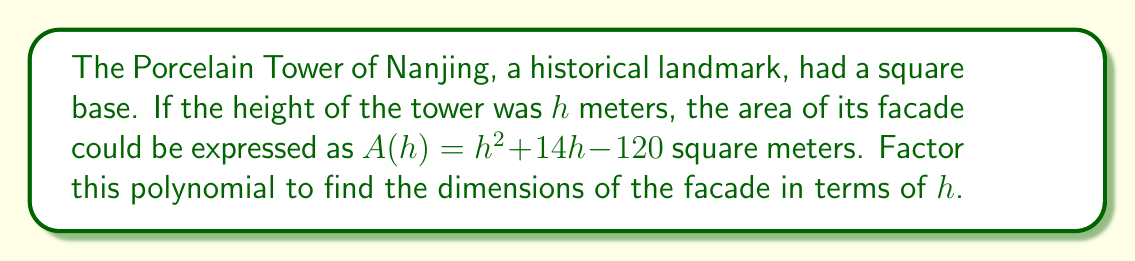Give your solution to this math problem. To factor the polynomial $A(h) = h^2 + 14h - 120$, we'll use the following steps:

1) First, identify that this is a quadratic polynomial in the form $ax^2 + bx + c$, where $a=1$, $b=14$, and $c=-120$.

2) We need to find two numbers that multiply to give $ac = 1 \times (-120) = -120$ and add up to $b = 14$.

3) These numbers are $20$ and $-6$, because $20 \times (-6) = -120$ and $20 + (-6) = 14$.

4) Rewrite the middle term using these numbers:
   $A(h) = h^2 + 20h - 6h - 120$

5) Group the terms:
   $A(h) = (h^2 + 20h) + (-6h - 120)$

6) Factor out the common factors from each group:
   $A(h) = h(h + 20) - 6(h + 20)$

7) Factor out the common binomial $(h + 20)$:
   $A(h) = (h - 6)(h + 20)$

This factored form $(h - 6)(h + 20)$ represents the dimensions of the facade. The width of the facade is $(h - 6)$ meters and the height is $(h + 20)$ meters, both expressed in terms of the tower's height $h$.
Answer: $(h - 6)(h + 20)$ 